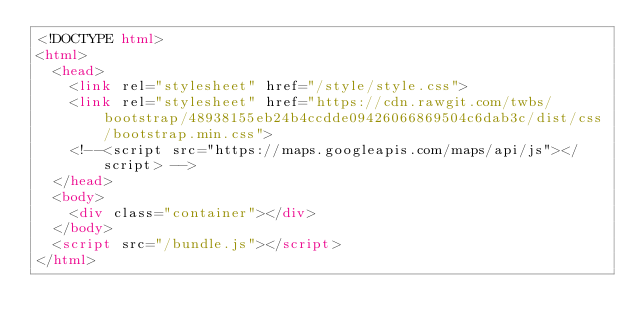<code> <loc_0><loc_0><loc_500><loc_500><_HTML_><!DOCTYPE html>
<html>
  <head>
    <link rel="stylesheet" href="/style/style.css">
    <link rel="stylesheet" href="https://cdn.rawgit.com/twbs/bootstrap/48938155eb24b4ccdde09426066869504c6dab3c/dist/css/bootstrap.min.css">
    <!--<script src="https://maps.googleapis.com/maps/api/js"></script> -->
  </head>
  <body>
    <div class="container"></div>
  </body>
  <script src="/bundle.js"></script>
</html>
</code> 